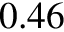<formula> <loc_0><loc_0><loc_500><loc_500>0 . 4 6</formula> 